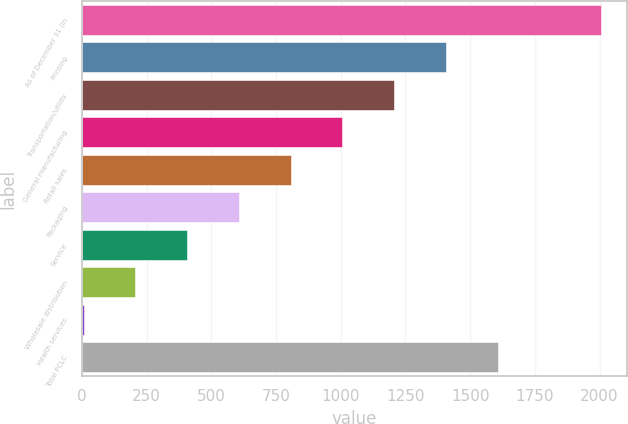Convert chart to OTSL. <chart><loc_0><loc_0><loc_500><loc_500><bar_chart><fcel>As of December 31 (in<fcel>Printing<fcel>Transportation/utility<fcel>General manufacturing<fcel>Retail sales<fcel>Packaging<fcel>Service<fcel>Wholesale distribution<fcel>Health services<fcel>Total PCLC<nl><fcel>2006<fcel>1406.24<fcel>1206.32<fcel>1006.4<fcel>806.48<fcel>606.56<fcel>406.64<fcel>206.72<fcel>6.8<fcel>1606.16<nl></chart> 